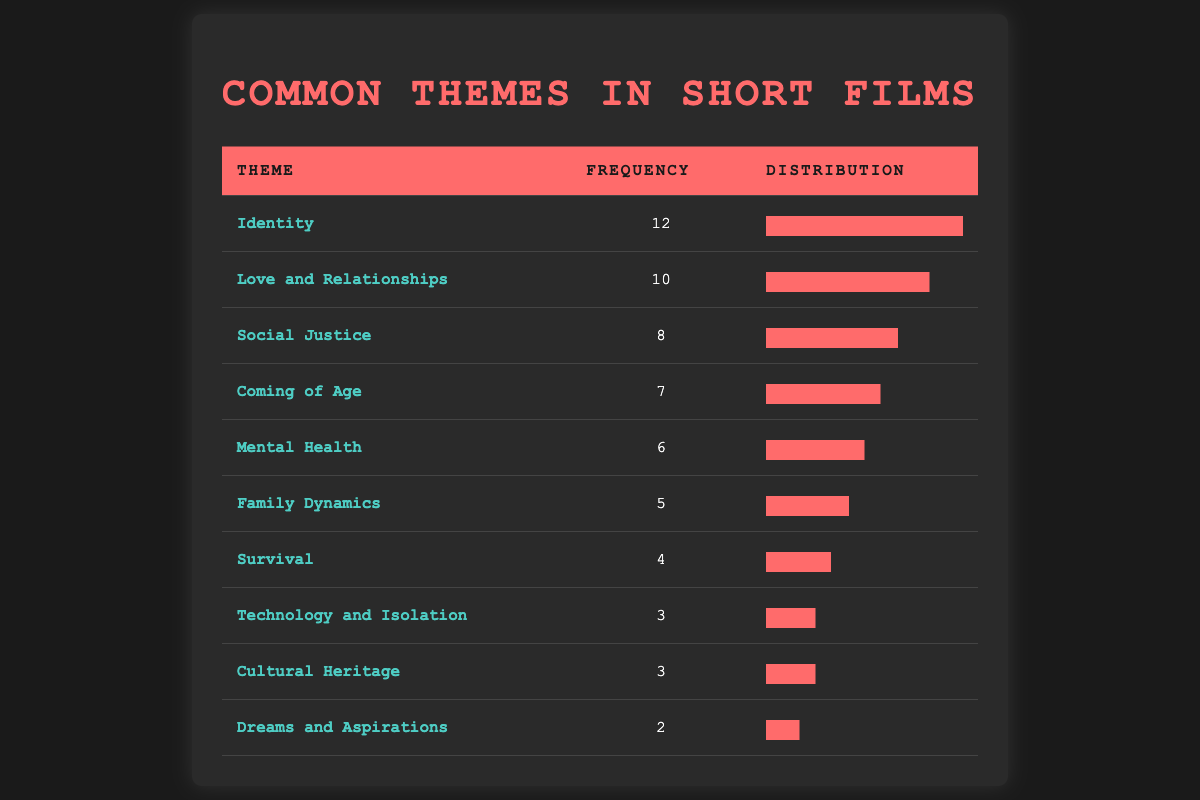What is the theme with the highest frequency? The table lists the themes and their corresponding frequencies. The theme with the highest frequency, which is the most commonly appearing theme, is "Identity" with a frequency of 12.
Answer: Identity How many themes have a frequency of 3 or more? By examining the table, we can count the entries with a frequency of 3 or more. The themes "Identity" (12), "Love and Relationships" (10), "Social Justice" (8), "Coming of Age" (7), "Mental Health" (6), "Family Dynamics" (5), and "Survival" (4) all meet this criterion. This gives us a total of 7 themes.
Answer: 7 What is the total frequency of all themes combined? To find the total frequency, we add all the individual frequencies: 12 + 10 + 8 + 7 + 6 + 5 + 4 + 3 + 3 + 2 = 60. Therefore, the total frequency of all themes combined is 60.
Answer: 60 Is the theme "Technology and Isolation" among the top three most common themes? We look at the frequencies of the themes and see that "Technology and Isolation" has a frequency of 3. The top three themes by frequency are "Identity" (12), "Love and Relationships" (10), and "Social Justice" (8). Since "Technology and Isolation" ranks lower than these, it is not among the top three.
Answer: No What percentage of the total frequency does the theme "Mental Health" represent? First, we take the frequency of "Mental Health," which is 6, and the total frequency we calculated earlier, which is 60. The percentage is calculated as (6 / 60) * 100 = 10%. Therefore, "Mental Health" represents 10% of the total frequency.
Answer: 10% How many more submissions focused on "Identity" compared to "Dreams and Aspirations"? The frequency of "Identity" is 12, and the frequency of "Dreams and Aspirations" is 2. To find the difference, we subtract the frequency of "Dreams and Aspirations" from that of "Identity": 12 - 2 = 10. This means there are 10 more submissions focused on "Identity."
Answer: 10 Identify all themes with a frequency less than 5. Upon reviewing the table, we see that the themes with a frequency less than 5 are "Survival" (4), "Technology and Isolation" (3), "Cultural Heritage" (3), and "Dreams and Aspirations" (2). In total, there are 4 themes fitting this description.
Answer: 4 How would the frequencies change if "Love and Relationships" received two more submissions? The current frequency of "Love and Relationships" is 10. If it received two new submissions, its frequency would increase to 10 + 2 = 12. This would not change its ranking significantly since "Identity" also has 12, but we need to reassess.
Answer: Frequency becomes 12 